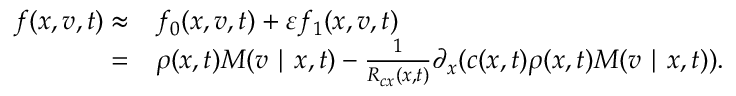Convert formula to latex. <formula><loc_0><loc_0><loc_500><loc_500>\begin{array} { r l } { f ( x , v , t ) \approx } & f _ { 0 } ( x , v , t ) + \varepsilon f _ { 1 } ( x , v , t ) } \\ { = } & \rho ( x , t ) M ( v | x , t ) - \frac { 1 } { R _ { c x } ( x , t ) } \partial _ { x } ( c ( x , t ) \rho ( x , t ) M ( v | x , t ) ) . } \end{array}</formula> 